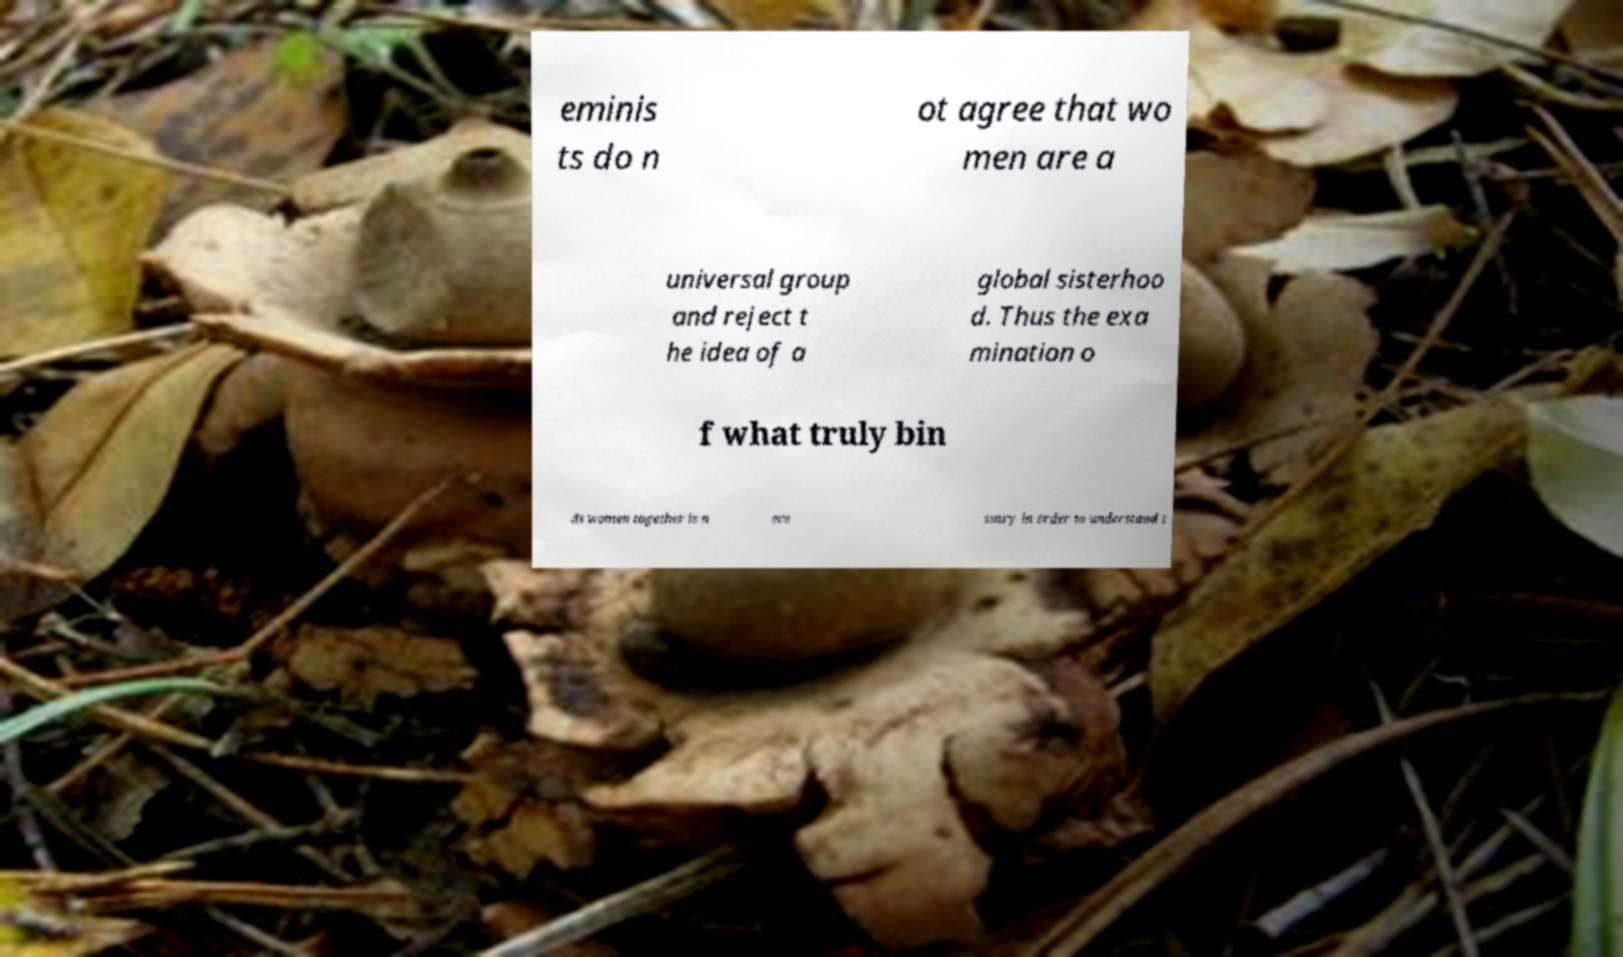Could you assist in decoding the text presented in this image and type it out clearly? eminis ts do n ot agree that wo men are a universal group and reject t he idea of a global sisterhoo d. Thus the exa mination o f what truly bin ds women together is n ece ssary in order to understand t 